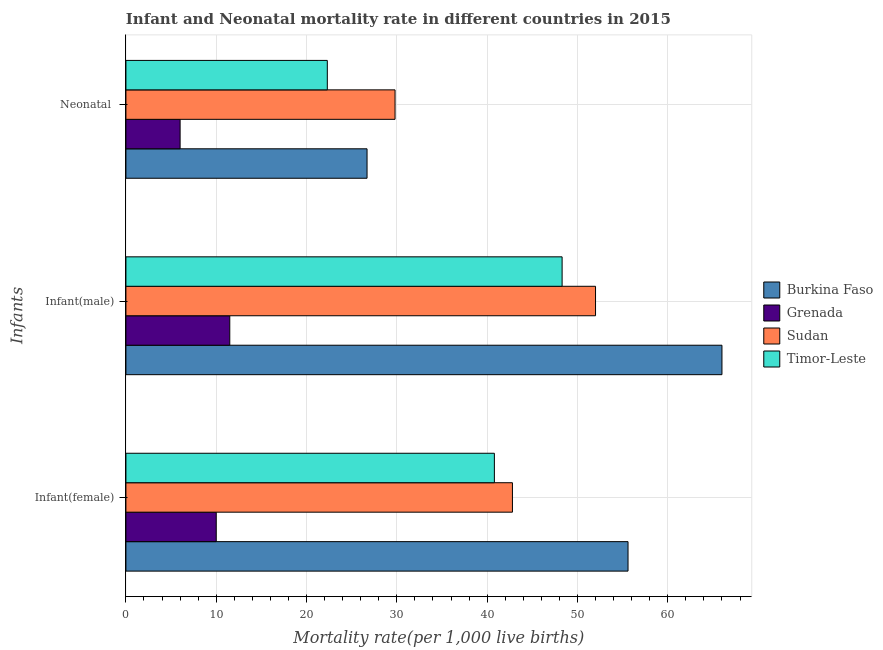Are the number of bars per tick equal to the number of legend labels?
Offer a terse response. Yes. Are the number of bars on each tick of the Y-axis equal?
Keep it short and to the point. Yes. What is the label of the 1st group of bars from the top?
Keep it short and to the point. Neonatal . What is the neonatal mortality rate in Burkina Faso?
Keep it short and to the point. 26.7. Across all countries, what is the maximum infant mortality rate(male)?
Offer a very short reply. 66. Across all countries, what is the minimum infant mortality rate(female)?
Your answer should be compact. 10. In which country was the infant mortality rate(female) maximum?
Make the answer very short. Burkina Faso. In which country was the infant mortality rate(female) minimum?
Your response must be concise. Grenada. What is the total neonatal mortality rate in the graph?
Your answer should be compact. 84.8. What is the difference between the infant mortality rate(male) in Burkina Faso and that in Sudan?
Provide a succinct answer. 14. What is the difference between the infant mortality rate(male) in Burkina Faso and the neonatal mortality rate in Sudan?
Your response must be concise. 36.2. What is the average infant mortality rate(female) per country?
Your response must be concise. 37.3. What is the difference between the infant mortality rate(female) and neonatal mortality rate in Sudan?
Your response must be concise. 13. In how many countries, is the infant mortality rate(female) greater than 56 ?
Give a very brief answer. 0. What is the ratio of the infant mortality rate(female) in Burkina Faso to that in Timor-Leste?
Keep it short and to the point. 1.36. Is the neonatal mortality rate in Grenada less than that in Burkina Faso?
Your response must be concise. Yes. Is the difference between the infant mortality rate(male) in Timor-Leste and Grenada greater than the difference between the neonatal mortality rate in Timor-Leste and Grenada?
Keep it short and to the point. Yes. What is the difference between the highest and the second highest infant mortality rate(male)?
Your answer should be very brief. 14. What is the difference between the highest and the lowest infant mortality rate(male)?
Keep it short and to the point. 54.5. In how many countries, is the neonatal mortality rate greater than the average neonatal mortality rate taken over all countries?
Your response must be concise. 3. What does the 4th bar from the top in Infant(female) represents?
Your response must be concise. Burkina Faso. What does the 2nd bar from the bottom in Infant(male) represents?
Provide a short and direct response. Grenada. What is the difference between two consecutive major ticks on the X-axis?
Ensure brevity in your answer.  10. How are the legend labels stacked?
Your answer should be very brief. Vertical. What is the title of the graph?
Offer a terse response. Infant and Neonatal mortality rate in different countries in 2015. Does "Italy" appear as one of the legend labels in the graph?
Provide a short and direct response. No. What is the label or title of the X-axis?
Ensure brevity in your answer.  Mortality rate(per 1,0 live births). What is the label or title of the Y-axis?
Your answer should be very brief. Infants. What is the Mortality rate(per 1,000 live births) of Burkina Faso in Infant(female)?
Provide a short and direct response. 55.6. What is the Mortality rate(per 1,000 live births) of Grenada in Infant(female)?
Ensure brevity in your answer.  10. What is the Mortality rate(per 1,000 live births) of Sudan in Infant(female)?
Your answer should be compact. 42.8. What is the Mortality rate(per 1,000 live births) of Timor-Leste in Infant(female)?
Your response must be concise. 40.8. What is the Mortality rate(per 1,000 live births) in Timor-Leste in Infant(male)?
Give a very brief answer. 48.3. What is the Mortality rate(per 1,000 live births) in Burkina Faso in Neonatal ?
Your response must be concise. 26.7. What is the Mortality rate(per 1,000 live births) in Grenada in Neonatal ?
Provide a short and direct response. 6. What is the Mortality rate(per 1,000 live births) of Sudan in Neonatal ?
Keep it short and to the point. 29.8. What is the Mortality rate(per 1,000 live births) in Timor-Leste in Neonatal ?
Offer a very short reply. 22.3. Across all Infants, what is the maximum Mortality rate(per 1,000 live births) of Grenada?
Your answer should be compact. 11.5. Across all Infants, what is the maximum Mortality rate(per 1,000 live births) in Sudan?
Offer a terse response. 52. Across all Infants, what is the maximum Mortality rate(per 1,000 live births) of Timor-Leste?
Offer a terse response. 48.3. Across all Infants, what is the minimum Mortality rate(per 1,000 live births) in Burkina Faso?
Keep it short and to the point. 26.7. Across all Infants, what is the minimum Mortality rate(per 1,000 live births) of Sudan?
Ensure brevity in your answer.  29.8. Across all Infants, what is the minimum Mortality rate(per 1,000 live births) in Timor-Leste?
Give a very brief answer. 22.3. What is the total Mortality rate(per 1,000 live births) in Burkina Faso in the graph?
Your answer should be compact. 148.3. What is the total Mortality rate(per 1,000 live births) of Sudan in the graph?
Your answer should be very brief. 124.6. What is the total Mortality rate(per 1,000 live births) of Timor-Leste in the graph?
Offer a very short reply. 111.4. What is the difference between the Mortality rate(per 1,000 live births) in Burkina Faso in Infant(female) and that in Infant(male)?
Your answer should be very brief. -10.4. What is the difference between the Mortality rate(per 1,000 live births) of Burkina Faso in Infant(female) and that in Neonatal ?
Give a very brief answer. 28.9. What is the difference between the Mortality rate(per 1,000 live births) in Burkina Faso in Infant(male) and that in Neonatal ?
Ensure brevity in your answer.  39.3. What is the difference between the Mortality rate(per 1,000 live births) of Grenada in Infant(male) and that in Neonatal ?
Offer a terse response. 5.5. What is the difference between the Mortality rate(per 1,000 live births) of Sudan in Infant(male) and that in Neonatal ?
Your answer should be very brief. 22.2. What is the difference between the Mortality rate(per 1,000 live births) of Timor-Leste in Infant(male) and that in Neonatal ?
Provide a succinct answer. 26. What is the difference between the Mortality rate(per 1,000 live births) in Burkina Faso in Infant(female) and the Mortality rate(per 1,000 live births) in Grenada in Infant(male)?
Offer a very short reply. 44.1. What is the difference between the Mortality rate(per 1,000 live births) in Burkina Faso in Infant(female) and the Mortality rate(per 1,000 live births) in Timor-Leste in Infant(male)?
Offer a very short reply. 7.3. What is the difference between the Mortality rate(per 1,000 live births) in Grenada in Infant(female) and the Mortality rate(per 1,000 live births) in Sudan in Infant(male)?
Provide a short and direct response. -42. What is the difference between the Mortality rate(per 1,000 live births) in Grenada in Infant(female) and the Mortality rate(per 1,000 live births) in Timor-Leste in Infant(male)?
Your answer should be compact. -38.3. What is the difference between the Mortality rate(per 1,000 live births) in Burkina Faso in Infant(female) and the Mortality rate(per 1,000 live births) in Grenada in Neonatal ?
Your answer should be compact. 49.6. What is the difference between the Mortality rate(per 1,000 live births) of Burkina Faso in Infant(female) and the Mortality rate(per 1,000 live births) of Sudan in Neonatal ?
Make the answer very short. 25.8. What is the difference between the Mortality rate(per 1,000 live births) in Burkina Faso in Infant(female) and the Mortality rate(per 1,000 live births) in Timor-Leste in Neonatal ?
Offer a terse response. 33.3. What is the difference between the Mortality rate(per 1,000 live births) of Grenada in Infant(female) and the Mortality rate(per 1,000 live births) of Sudan in Neonatal ?
Ensure brevity in your answer.  -19.8. What is the difference between the Mortality rate(per 1,000 live births) in Burkina Faso in Infant(male) and the Mortality rate(per 1,000 live births) in Sudan in Neonatal ?
Your answer should be very brief. 36.2. What is the difference between the Mortality rate(per 1,000 live births) of Burkina Faso in Infant(male) and the Mortality rate(per 1,000 live births) of Timor-Leste in Neonatal ?
Your answer should be very brief. 43.7. What is the difference between the Mortality rate(per 1,000 live births) in Grenada in Infant(male) and the Mortality rate(per 1,000 live births) in Sudan in Neonatal ?
Ensure brevity in your answer.  -18.3. What is the difference between the Mortality rate(per 1,000 live births) of Grenada in Infant(male) and the Mortality rate(per 1,000 live births) of Timor-Leste in Neonatal ?
Your answer should be compact. -10.8. What is the difference between the Mortality rate(per 1,000 live births) of Sudan in Infant(male) and the Mortality rate(per 1,000 live births) of Timor-Leste in Neonatal ?
Your response must be concise. 29.7. What is the average Mortality rate(per 1,000 live births) in Burkina Faso per Infants?
Give a very brief answer. 49.43. What is the average Mortality rate(per 1,000 live births) of Grenada per Infants?
Offer a very short reply. 9.17. What is the average Mortality rate(per 1,000 live births) in Sudan per Infants?
Offer a very short reply. 41.53. What is the average Mortality rate(per 1,000 live births) in Timor-Leste per Infants?
Your response must be concise. 37.13. What is the difference between the Mortality rate(per 1,000 live births) of Burkina Faso and Mortality rate(per 1,000 live births) of Grenada in Infant(female)?
Your answer should be compact. 45.6. What is the difference between the Mortality rate(per 1,000 live births) of Grenada and Mortality rate(per 1,000 live births) of Sudan in Infant(female)?
Offer a very short reply. -32.8. What is the difference between the Mortality rate(per 1,000 live births) of Grenada and Mortality rate(per 1,000 live births) of Timor-Leste in Infant(female)?
Keep it short and to the point. -30.8. What is the difference between the Mortality rate(per 1,000 live births) in Burkina Faso and Mortality rate(per 1,000 live births) in Grenada in Infant(male)?
Offer a terse response. 54.5. What is the difference between the Mortality rate(per 1,000 live births) of Burkina Faso and Mortality rate(per 1,000 live births) of Timor-Leste in Infant(male)?
Your response must be concise. 17.7. What is the difference between the Mortality rate(per 1,000 live births) in Grenada and Mortality rate(per 1,000 live births) in Sudan in Infant(male)?
Offer a terse response. -40.5. What is the difference between the Mortality rate(per 1,000 live births) in Grenada and Mortality rate(per 1,000 live births) in Timor-Leste in Infant(male)?
Make the answer very short. -36.8. What is the difference between the Mortality rate(per 1,000 live births) of Sudan and Mortality rate(per 1,000 live births) of Timor-Leste in Infant(male)?
Keep it short and to the point. 3.7. What is the difference between the Mortality rate(per 1,000 live births) in Burkina Faso and Mortality rate(per 1,000 live births) in Grenada in Neonatal ?
Offer a very short reply. 20.7. What is the difference between the Mortality rate(per 1,000 live births) of Burkina Faso and Mortality rate(per 1,000 live births) of Sudan in Neonatal ?
Make the answer very short. -3.1. What is the difference between the Mortality rate(per 1,000 live births) in Burkina Faso and Mortality rate(per 1,000 live births) in Timor-Leste in Neonatal ?
Give a very brief answer. 4.4. What is the difference between the Mortality rate(per 1,000 live births) of Grenada and Mortality rate(per 1,000 live births) of Sudan in Neonatal ?
Your answer should be very brief. -23.8. What is the difference between the Mortality rate(per 1,000 live births) of Grenada and Mortality rate(per 1,000 live births) of Timor-Leste in Neonatal ?
Your answer should be very brief. -16.3. What is the ratio of the Mortality rate(per 1,000 live births) of Burkina Faso in Infant(female) to that in Infant(male)?
Your answer should be compact. 0.84. What is the ratio of the Mortality rate(per 1,000 live births) of Grenada in Infant(female) to that in Infant(male)?
Ensure brevity in your answer.  0.87. What is the ratio of the Mortality rate(per 1,000 live births) in Sudan in Infant(female) to that in Infant(male)?
Your response must be concise. 0.82. What is the ratio of the Mortality rate(per 1,000 live births) of Timor-Leste in Infant(female) to that in Infant(male)?
Provide a succinct answer. 0.84. What is the ratio of the Mortality rate(per 1,000 live births) of Burkina Faso in Infant(female) to that in Neonatal ?
Ensure brevity in your answer.  2.08. What is the ratio of the Mortality rate(per 1,000 live births) in Sudan in Infant(female) to that in Neonatal ?
Your answer should be compact. 1.44. What is the ratio of the Mortality rate(per 1,000 live births) in Timor-Leste in Infant(female) to that in Neonatal ?
Your answer should be compact. 1.83. What is the ratio of the Mortality rate(per 1,000 live births) in Burkina Faso in Infant(male) to that in Neonatal ?
Your response must be concise. 2.47. What is the ratio of the Mortality rate(per 1,000 live births) in Grenada in Infant(male) to that in Neonatal ?
Offer a terse response. 1.92. What is the ratio of the Mortality rate(per 1,000 live births) in Sudan in Infant(male) to that in Neonatal ?
Your response must be concise. 1.75. What is the ratio of the Mortality rate(per 1,000 live births) of Timor-Leste in Infant(male) to that in Neonatal ?
Make the answer very short. 2.17. What is the difference between the highest and the second highest Mortality rate(per 1,000 live births) of Grenada?
Give a very brief answer. 1.5. What is the difference between the highest and the lowest Mortality rate(per 1,000 live births) of Burkina Faso?
Offer a very short reply. 39.3. What is the difference between the highest and the lowest Mortality rate(per 1,000 live births) in Timor-Leste?
Your response must be concise. 26. 